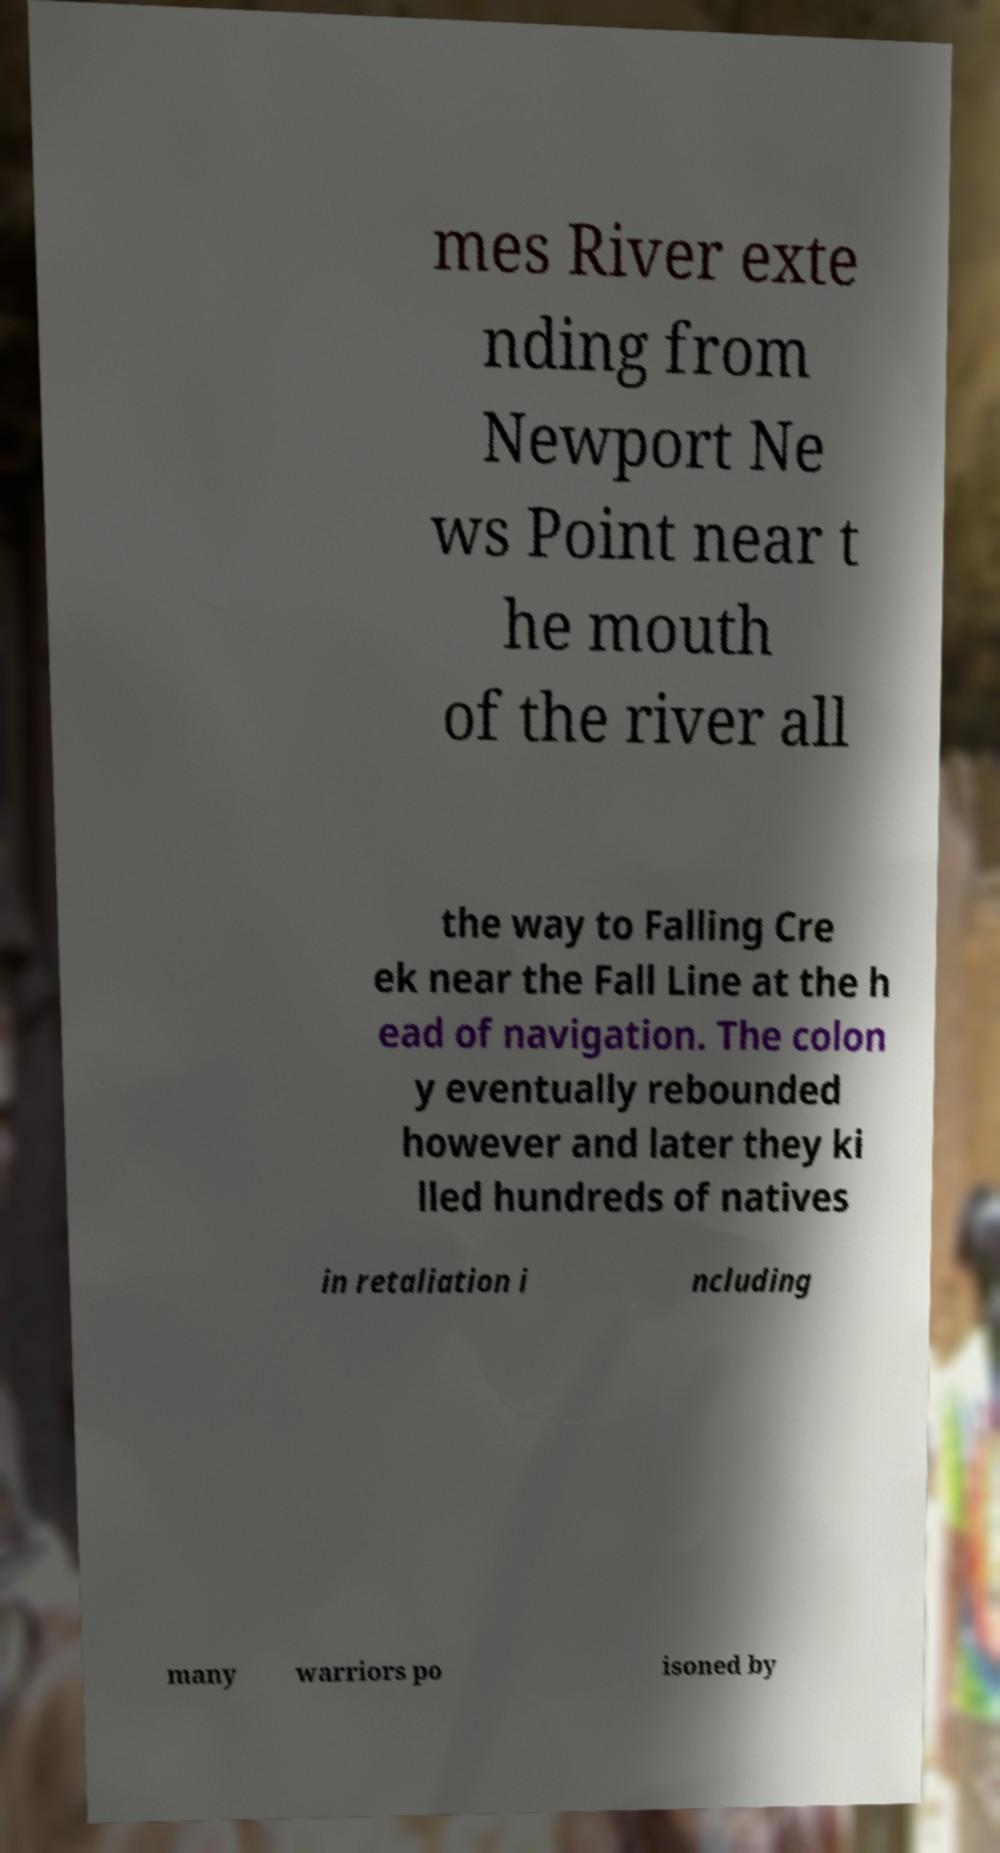Could you assist in decoding the text presented in this image and type it out clearly? mes River exte nding from Newport Ne ws Point near t he mouth of the river all the way to Falling Cre ek near the Fall Line at the h ead of navigation. The colon y eventually rebounded however and later they ki lled hundreds of natives in retaliation i ncluding many warriors po isoned by 